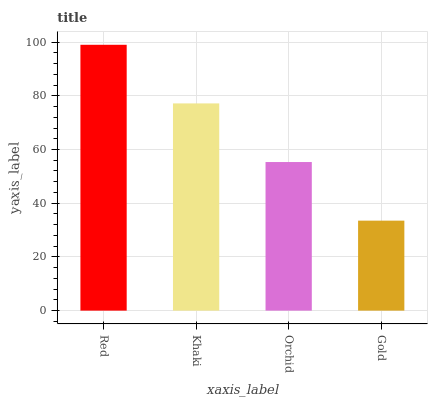Is Gold the minimum?
Answer yes or no. Yes. Is Red the maximum?
Answer yes or no. Yes. Is Khaki the minimum?
Answer yes or no. No. Is Khaki the maximum?
Answer yes or no. No. Is Red greater than Khaki?
Answer yes or no. Yes. Is Khaki less than Red?
Answer yes or no. Yes. Is Khaki greater than Red?
Answer yes or no. No. Is Red less than Khaki?
Answer yes or no. No. Is Khaki the high median?
Answer yes or no. Yes. Is Orchid the low median?
Answer yes or no. Yes. Is Red the high median?
Answer yes or no. No. Is Red the low median?
Answer yes or no. No. 